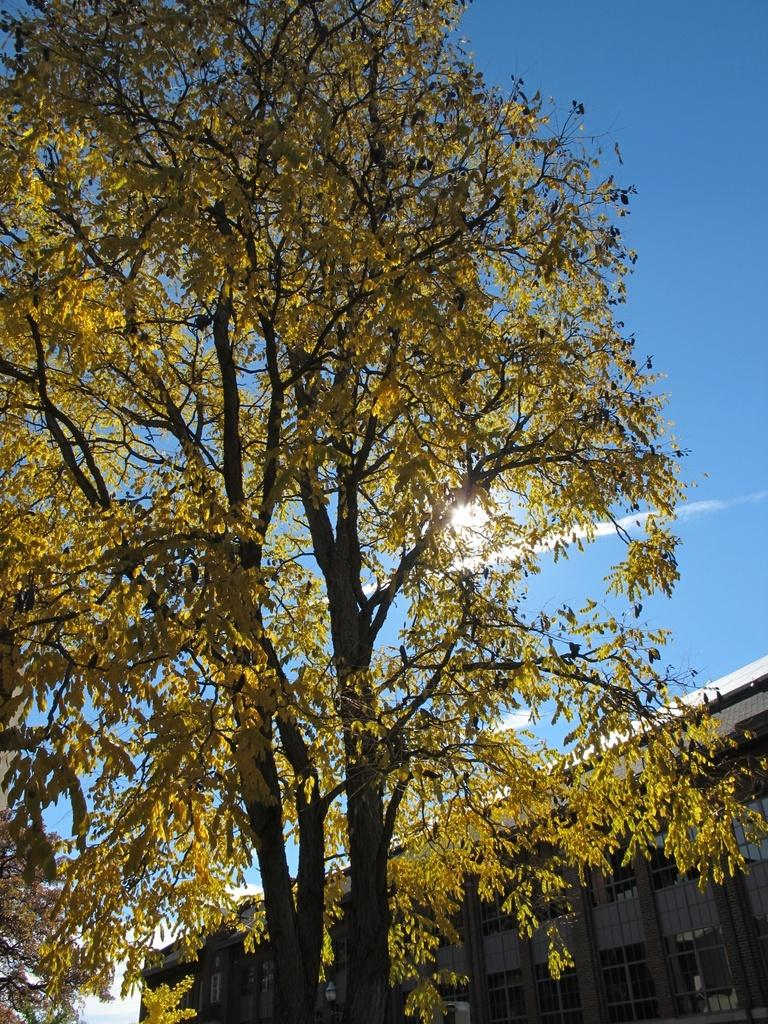What type of natural elements can be seen in the image? There are trees in the image. What type of man-made structures are present in the image? There are buildings in the image. What is the source of light in the background of the image? There is sunlight visible in the background of the image. What is the name of the company that is manufacturing the liquid in the image? There is no liquid present in the image, and therefore no company associated with it. 